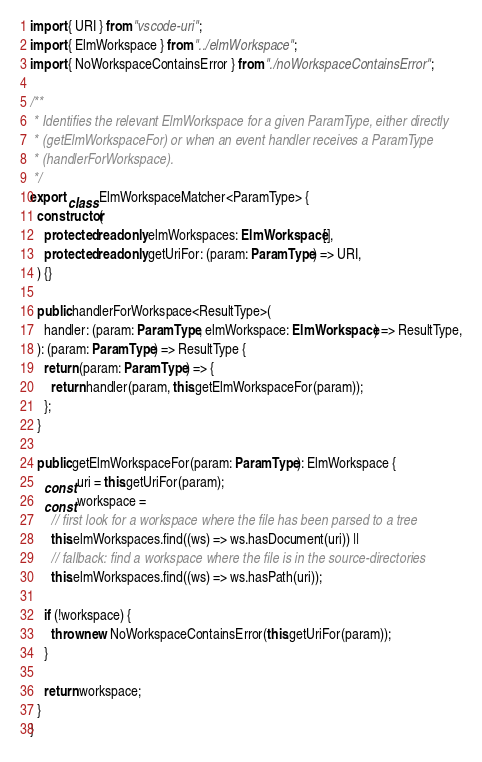Convert code to text. <code><loc_0><loc_0><loc_500><loc_500><_TypeScript_>import { URI } from "vscode-uri";
import { ElmWorkspace } from "../elmWorkspace";
import { NoWorkspaceContainsError } from "./noWorkspaceContainsError";

/**
 * Identifies the relevant ElmWorkspace for a given ParamType, either directly
 * (getElmWorkspaceFor) or when an event handler receives a ParamType
 * (handlerForWorkspace).
 */
export class ElmWorkspaceMatcher<ParamType> {
  constructor(
    protected readonly elmWorkspaces: ElmWorkspace[],
    protected readonly getUriFor: (param: ParamType) => URI,
  ) {}

  public handlerForWorkspace<ResultType>(
    handler: (param: ParamType, elmWorkspace: ElmWorkspace) => ResultType,
  ): (param: ParamType) => ResultType {
    return (param: ParamType) => {
      return handler(param, this.getElmWorkspaceFor(param));
    };
  }

  public getElmWorkspaceFor(param: ParamType): ElmWorkspace {
    const uri = this.getUriFor(param);
    const workspace =
      // first look for a workspace where the file has been parsed to a tree
      this.elmWorkspaces.find((ws) => ws.hasDocument(uri)) ||
      // fallback: find a workspace where the file is in the source-directories
      this.elmWorkspaces.find((ws) => ws.hasPath(uri));

    if (!workspace) {
      throw new NoWorkspaceContainsError(this.getUriFor(param));
    }

    return workspace;
  }
}
</code> 